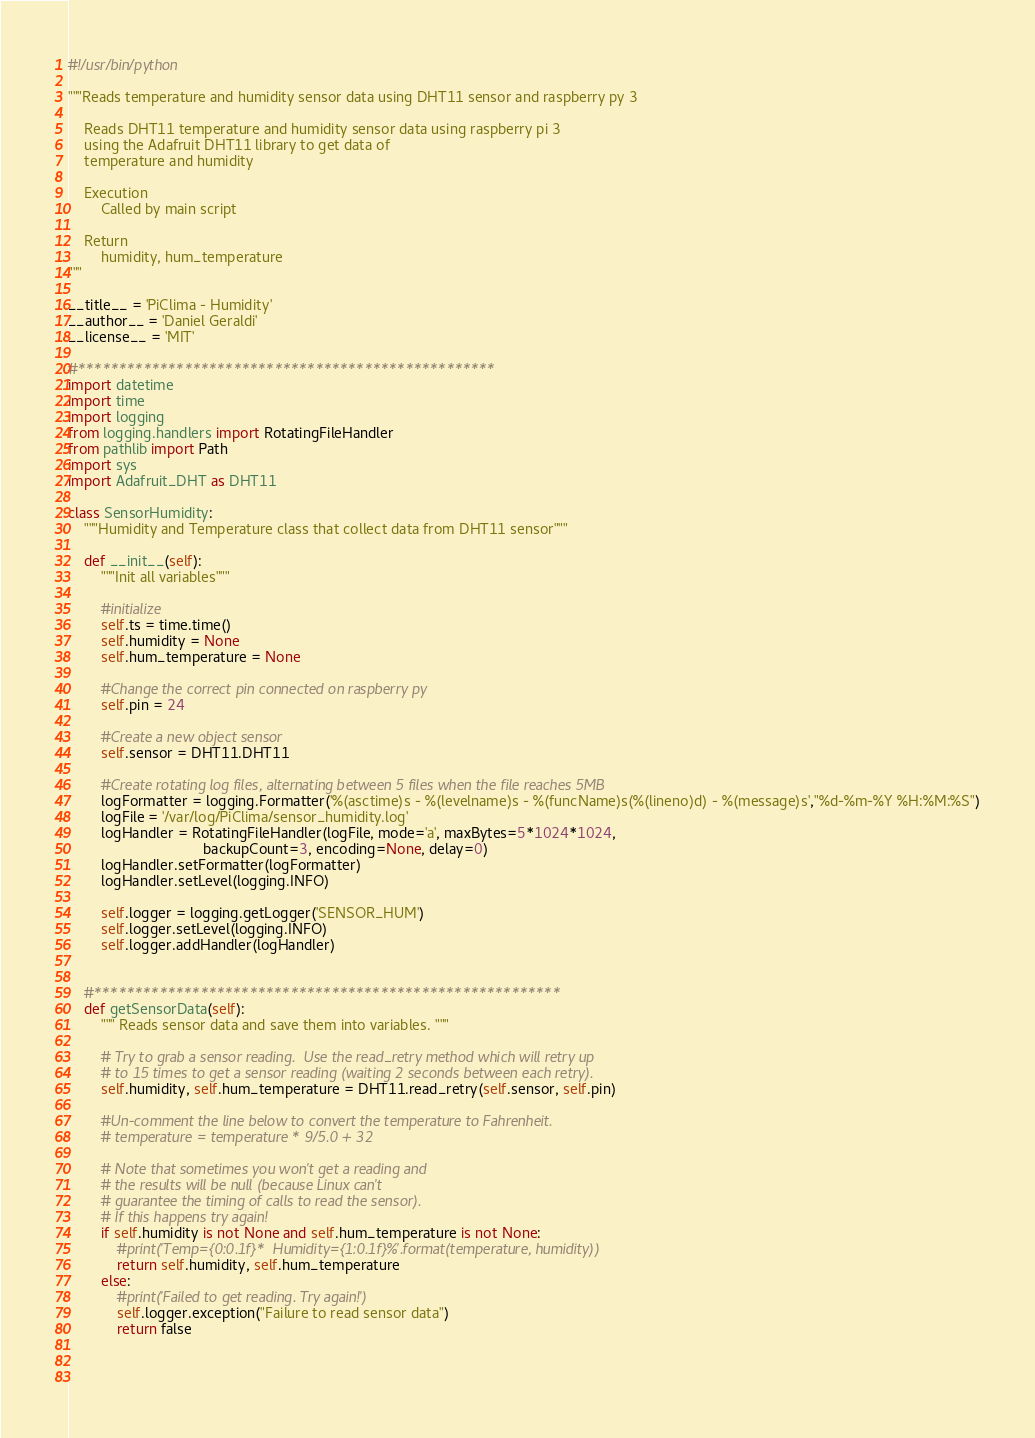<code> <loc_0><loc_0><loc_500><loc_500><_Python_>#!/usr/bin/python

"""Reads temperature and humidity sensor data using DHT11 sensor and raspberry py 3

	Reads DHT11 temperature and humidity sensor data using raspberry pi 3 
	using the Adafruit DHT11 library to get data of
	temperature and humidity

	Execution
		Called by main script

	Return
		humidity, hum_temperature
"""

__title__ = 'PiClima - Humidity'
__author__ = 'Daniel Geraldi'
__license__ = 'MIT'

#***************************************************
import datetime
import time
import logging
from logging.handlers import RotatingFileHandler
from pathlib import Path
import sys
import Adafruit_DHT as DHT11

class SensorHumidity:
	"""Humidity and Temperature class that collect data from DHT11 sensor"""

	def __init__(self):
		"""Init all variables"""

		#initialize
		self.ts = time.time()
		self.humidity = None
		self.hum_temperature = None

		#Change the correct pin connected on raspberry py
		self.pin = 24

		#Create a new object sensor
		self.sensor = DHT11.DHT11

		#Create rotating log files, alternating between 5 files when the file reaches 5MB
		logFormatter = logging.Formatter('%(asctime)s - %(levelname)s - %(funcName)s(%(lineno)d) - %(message)s',"%d-%m-%Y %H:%M:%S")
		logFile = '/var/log/PiClima/sensor_humidity.log'
		logHandler = RotatingFileHandler(logFile, mode='a', maxBytes=5*1024*1024, 
                                 backupCount=3, encoding=None, delay=0)
		logHandler.setFormatter(logFormatter)
		logHandler.setLevel(logging.INFO)

		self.logger = logging.getLogger('SENSOR_HUM')
		self.logger.setLevel(logging.INFO)
		self.logger.addHandler(logHandler)


	#*********************************************************
	def getSensorData(self):
		""" Reads sensor data and save them into variables. """

		# Try to grab a sensor reading.  Use the read_retry method which will retry up
		# to 15 times to get a sensor reading (waiting 2 seconds between each retry).
		self.humidity, self.hum_temperature = DHT11.read_retry(self.sensor, self.pin)

		#Un-comment the line below to convert the temperature to Fahrenheit.
		# temperature = temperature * 9/5.0 + 32

		# Note that sometimes you won't get a reading and
		# the results will be null (because Linux can't
		# guarantee the timing of calls to read the sensor).
		# If this happens try again!
		if self.humidity is not None and self.hum_temperature is not None:
			#print('Temp={0:0.1f}*  Humidity={1:0.1f}%'.format(temperature, humidity))
			return self.humidity, self.hum_temperature
		else:
			#print('Failed to get reading. Try again!')
			self.logger.exception("Failure to read sensor data")
			return false


		</code> 